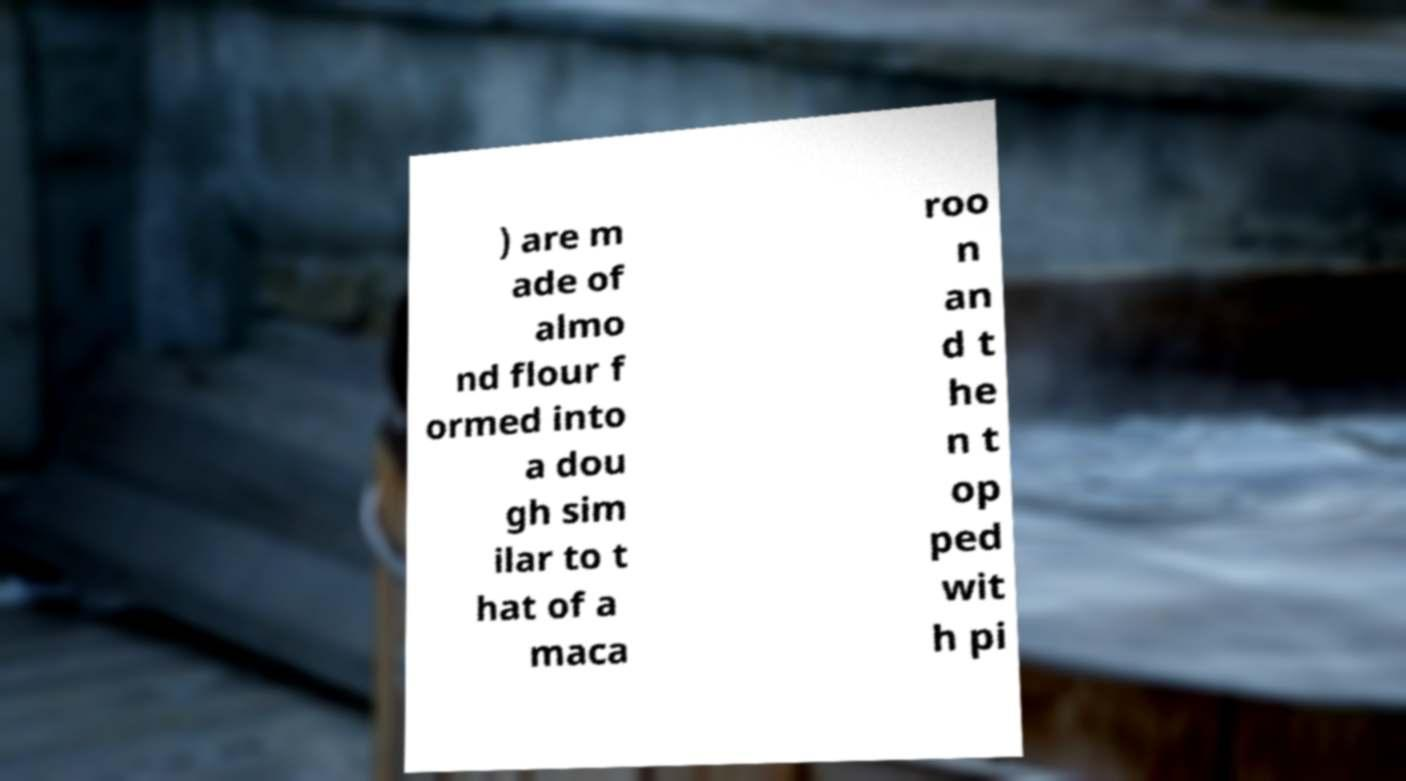Can you accurately transcribe the text from the provided image for me? ) are m ade of almo nd flour f ormed into a dou gh sim ilar to t hat of a maca roo n an d t he n t op ped wit h pi 